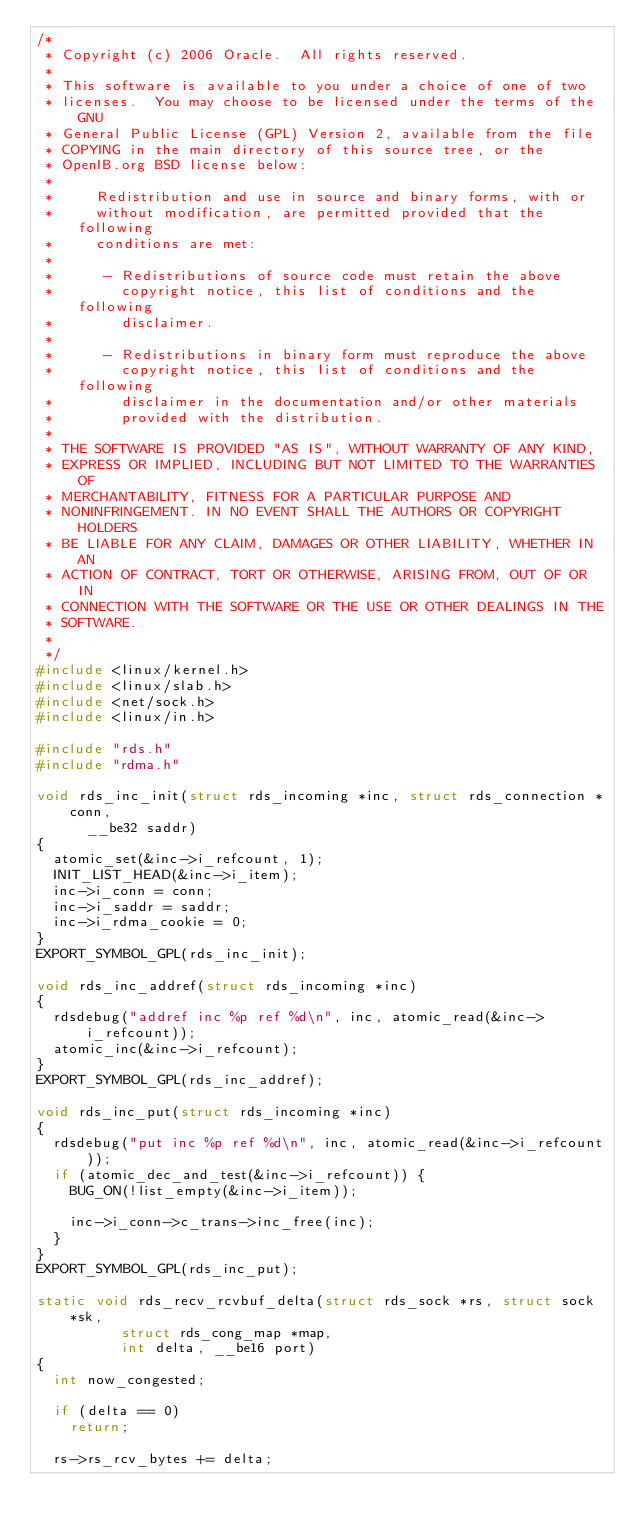Convert code to text. <code><loc_0><loc_0><loc_500><loc_500><_C_>/*
 * Copyright (c) 2006 Oracle.  All rights reserved.
 *
 * This software is available to you under a choice of one of two
 * licenses.  You may choose to be licensed under the terms of the GNU
 * General Public License (GPL) Version 2, available from the file
 * COPYING in the main directory of this source tree, or the
 * OpenIB.org BSD license below:
 *
 *     Redistribution and use in source and binary forms, with or
 *     without modification, are permitted provided that the following
 *     conditions are met:
 *
 *      - Redistributions of source code must retain the above
 *        copyright notice, this list of conditions and the following
 *        disclaimer.
 *
 *      - Redistributions in binary form must reproduce the above
 *        copyright notice, this list of conditions and the following
 *        disclaimer in the documentation and/or other materials
 *        provided with the distribution.
 *
 * THE SOFTWARE IS PROVIDED "AS IS", WITHOUT WARRANTY OF ANY KIND,
 * EXPRESS OR IMPLIED, INCLUDING BUT NOT LIMITED TO THE WARRANTIES OF
 * MERCHANTABILITY, FITNESS FOR A PARTICULAR PURPOSE AND
 * NONINFRINGEMENT. IN NO EVENT SHALL THE AUTHORS OR COPYRIGHT HOLDERS
 * BE LIABLE FOR ANY CLAIM, DAMAGES OR OTHER LIABILITY, WHETHER IN AN
 * ACTION OF CONTRACT, TORT OR OTHERWISE, ARISING FROM, OUT OF OR IN
 * CONNECTION WITH THE SOFTWARE OR THE USE OR OTHER DEALINGS IN THE
 * SOFTWARE.
 *
 */
#include <linux/kernel.h>
#include <linux/slab.h>
#include <net/sock.h>
#include <linux/in.h>

#include "rds.h"
#include "rdma.h"

void rds_inc_init(struct rds_incoming *inc, struct rds_connection *conn,
		  __be32 saddr)
{
	atomic_set(&inc->i_refcount, 1);
	INIT_LIST_HEAD(&inc->i_item);
	inc->i_conn = conn;
	inc->i_saddr = saddr;
	inc->i_rdma_cookie = 0;
}
EXPORT_SYMBOL_GPL(rds_inc_init);

void rds_inc_addref(struct rds_incoming *inc)
{
	rdsdebug("addref inc %p ref %d\n", inc, atomic_read(&inc->i_refcount));
	atomic_inc(&inc->i_refcount);
}
EXPORT_SYMBOL_GPL(rds_inc_addref);

void rds_inc_put(struct rds_incoming *inc)
{
	rdsdebug("put inc %p ref %d\n", inc, atomic_read(&inc->i_refcount));
	if (atomic_dec_and_test(&inc->i_refcount)) {
		BUG_ON(!list_empty(&inc->i_item));

		inc->i_conn->c_trans->inc_free(inc);
	}
}
EXPORT_SYMBOL_GPL(rds_inc_put);

static void rds_recv_rcvbuf_delta(struct rds_sock *rs, struct sock *sk,
				  struct rds_cong_map *map,
				  int delta, __be16 port)
{
	int now_congested;

	if (delta == 0)
		return;

	rs->rs_rcv_bytes += delta;</code> 